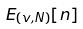<formula> <loc_0><loc_0><loc_500><loc_500>E _ { ( v , N ) } [ n ]</formula> 